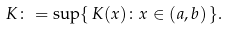Convert formula to latex. <formula><loc_0><loc_0><loc_500><loc_500>K \colon = \sup \{ \, K ( x ) \colon x \in ( a , b ) \, \} .</formula> 